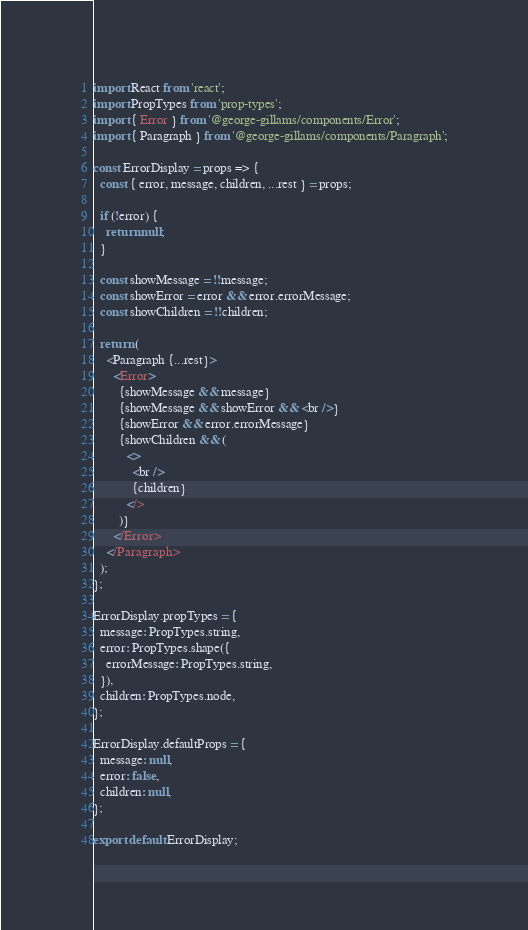<code> <loc_0><loc_0><loc_500><loc_500><_JavaScript_>import React from 'react';
import PropTypes from 'prop-types';
import { Error } from '@george-gillams/components/Error';
import { Paragraph } from '@george-gillams/components/Paragraph';

const ErrorDisplay = props => {
  const { error, message, children, ...rest } = props;

  if (!error) {
    return null;
  }

  const showMessage = !!message;
  const showError = error && error.errorMessage;
  const showChildren = !!children;

  return (
    <Paragraph {...rest}>
      <Error>
        {showMessage && message}
        {showMessage && showError && <br />}
        {showError && error.errorMessage}
        {showChildren && (
          <>
            <br />
            {children}
          </>
        )}
      </Error>
    </Paragraph>
  );
};

ErrorDisplay.propTypes = {
  message: PropTypes.string,
  error: PropTypes.shape({
    errorMessage: PropTypes.string,
  }),
  children: PropTypes.node,
};

ErrorDisplay.defaultProps = {
  message: null,
  error: false,
  children: null,
};

export default ErrorDisplay;
</code> 